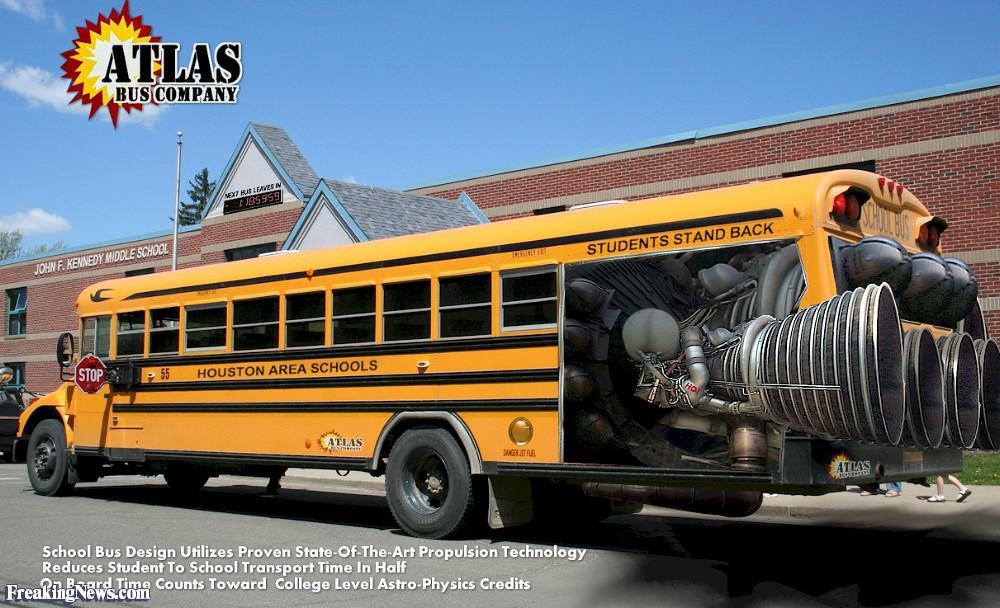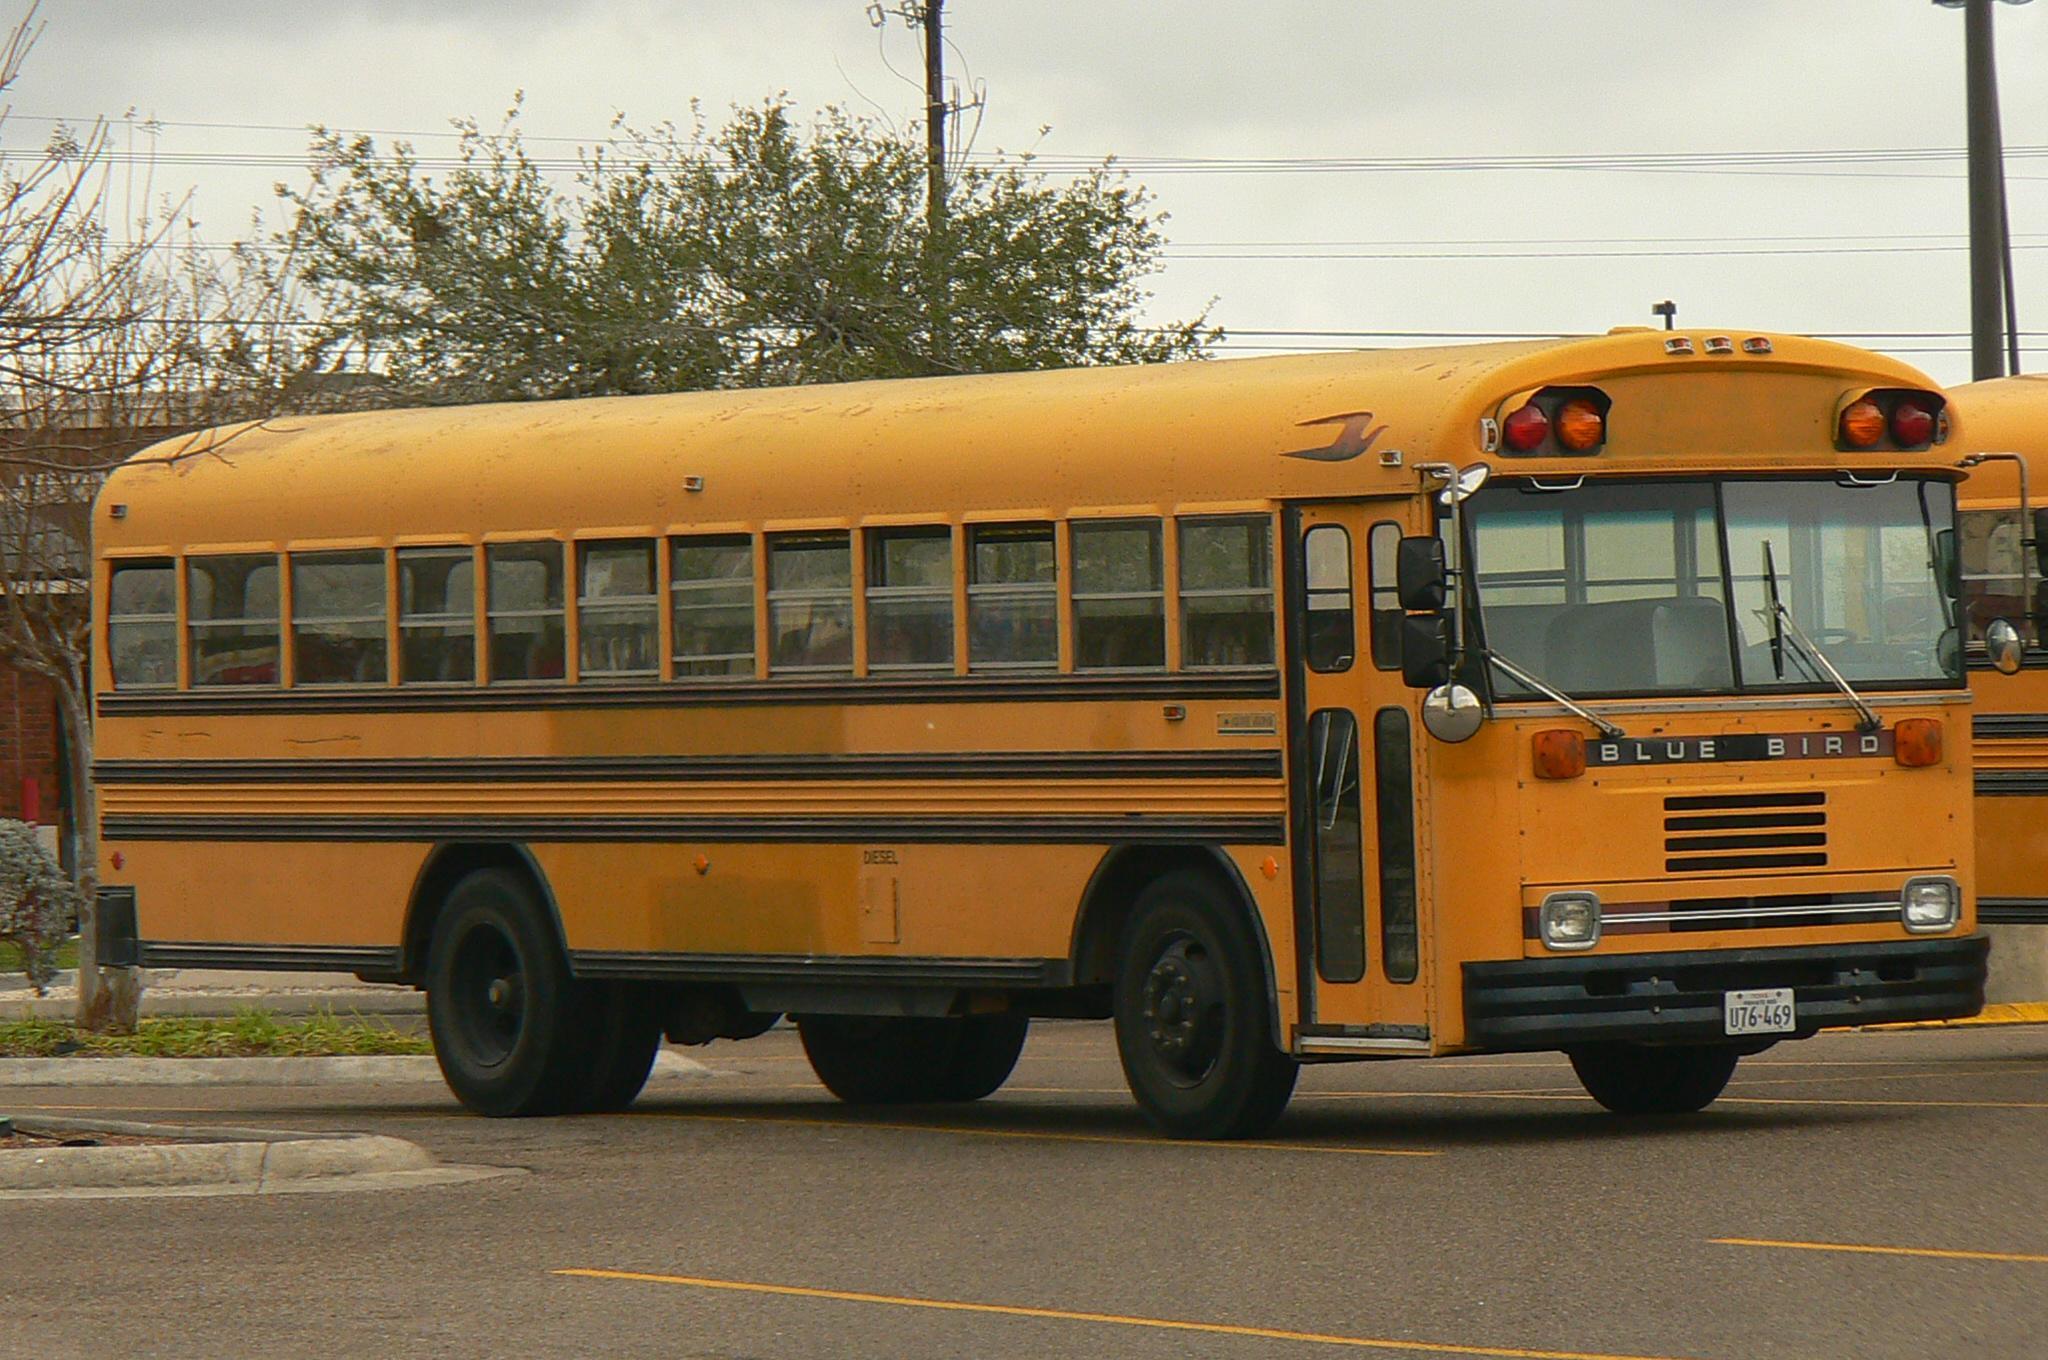The first image is the image on the left, the second image is the image on the right. Examine the images to the left and right. Is the description "The buses on the left and right face opposite directions, and one has a flat front while the other has a hood that projects forward." accurate? Answer yes or no. Yes. 